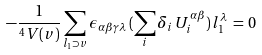Convert formula to latex. <formula><loc_0><loc_0><loc_500><loc_500>- \frac { 1 } { ^ { 4 } V ( v ) } \sum _ { l _ { 1 } \supset v } \epsilon _ { \alpha \beta \gamma \lambda } \, ( \sum _ { i } \delta _ { i } \, U _ { i } ^ { \alpha \beta } ) \, l _ { 1 } ^ { \lambda } \, = \, 0</formula> 